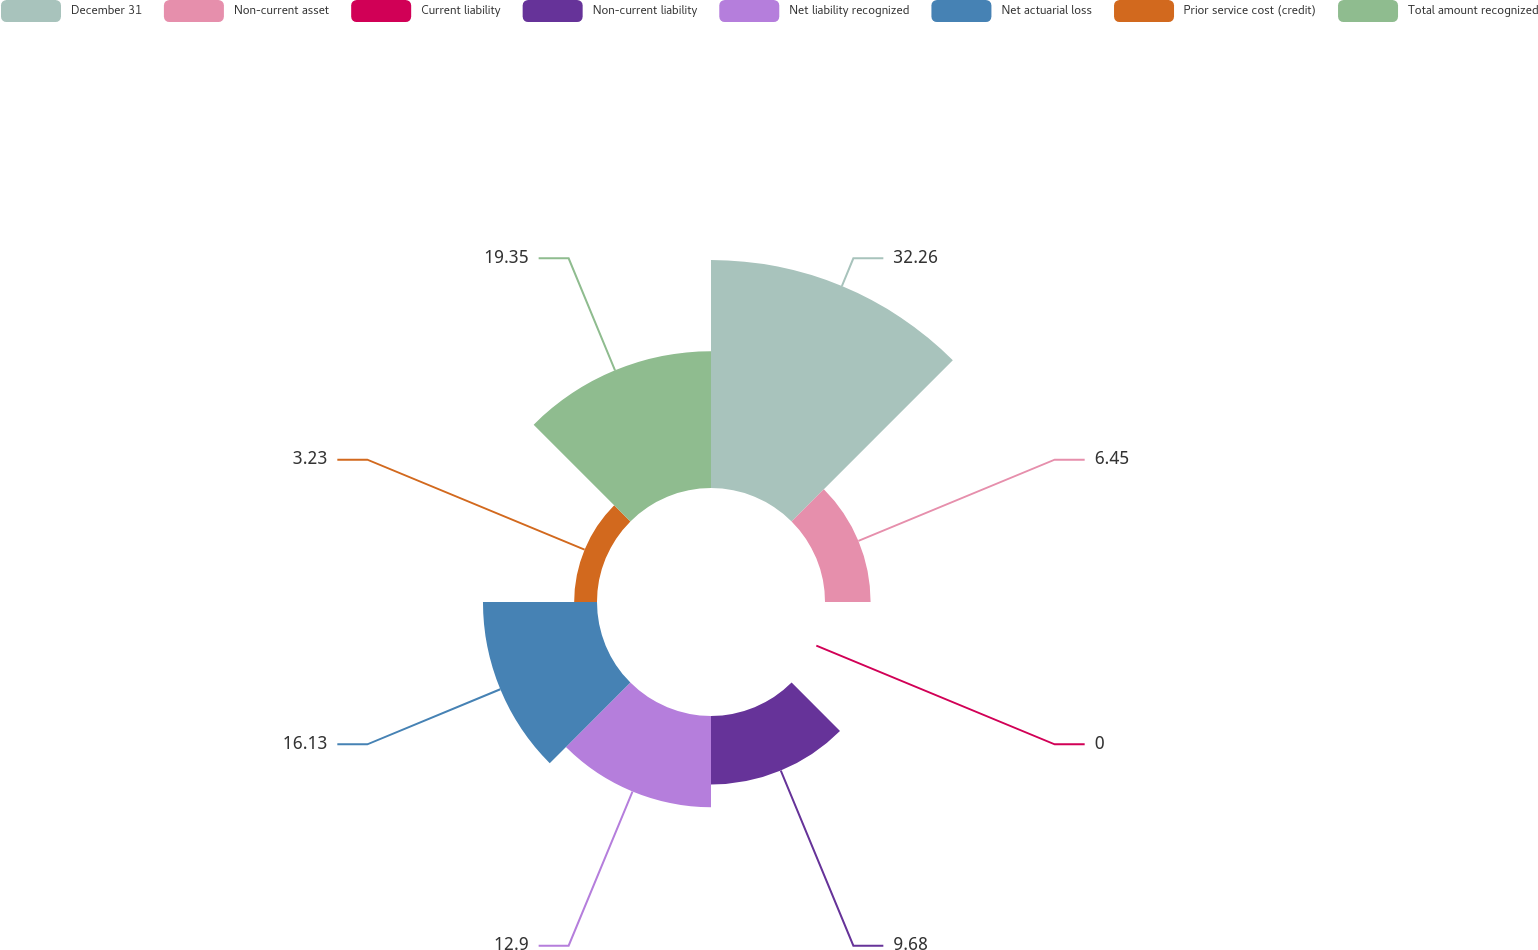<chart> <loc_0><loc_0><loc_500><loc_500><pie_chart><fcel>December 31<fcel>Non-current asset<fcel>Current liability<fcel>Non-current liability<fcel>Net liability recognized<fcel>Net actuarial loss<fcel>Prior service cost (credit)<fcel>Total amount recognized<nl><fcel>32.25%<fcel>6.45%<fcel>0.0%<fcel>9.68%<fcel>12.9%<fcel>16.13%<fcel>3.23%<fcel>19.35%<nl></chart> 